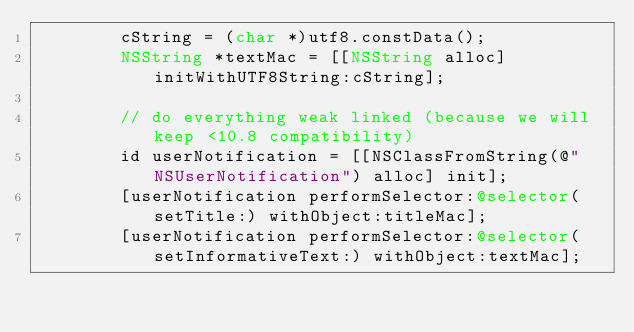Convert code to text. <code><loc_0><loc_0><loc_500><loc_500><_ObjectiveC_>        cString = (char *)utf8.constData();
        NSString *textMac = [[NSString alloc] initWithUTF8String:cString];

        // do everything weak linked (because we will keep <10.8 compatibility)
        id userNotification = [[NSClassFromString(@"NSUserNotification") alloc] init];
        [userNotification performSelector:@selector(setTitle:) withObject:titleMac];
        [userNotification performSelector:@selector(setInformativeText:) withObject:textMac];
</code> 